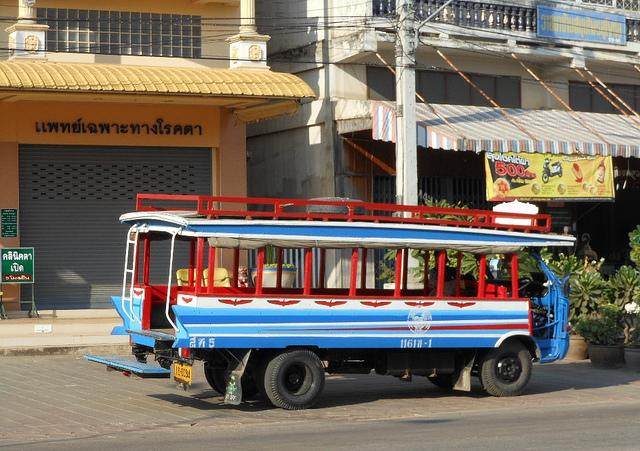The color scheme of this vehicle represents what flag?

Choices:
A) kazakhstan
B) djibouti
C) france
D) mexico france 